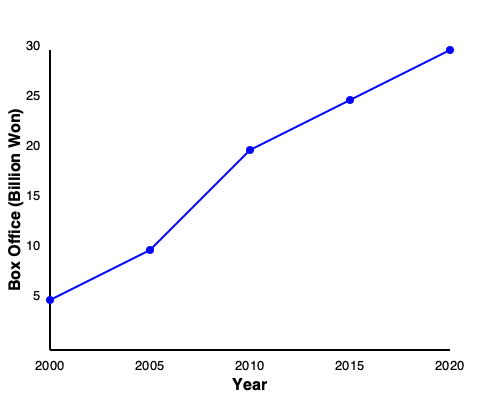Based on the chart showing Park Jeong-ja's film box office success over time, what was the approximate box office revenue (in billion won) for her films in 2010? To answer this question, we need to follow these steps:

1. Identify the x-axis (Year) and y-axis (Box Office in Billion Won) of the chart.
2. Locate the year 2010 on the x-axis.
3. Find the corresponding point on the blue line for the year 2010.
4. Estimate the y-axis value for this point.

Looking at the x-axis, we can see that 2010 is represented by the middle point on the axis.

Following the vertical line from 2010 up to where it intersects with the blue line, we can see that the point falls approximately at the 20 billion won mark on the y-axis.

To be more precise, the point seems to be slightly below the 20 billion won mark, around 18-19 billion won.

Therefore, the approximate box office revenue for Park Jeong-ja's films in 2010 was about 20 billion won.
Answer: 20 billion won 